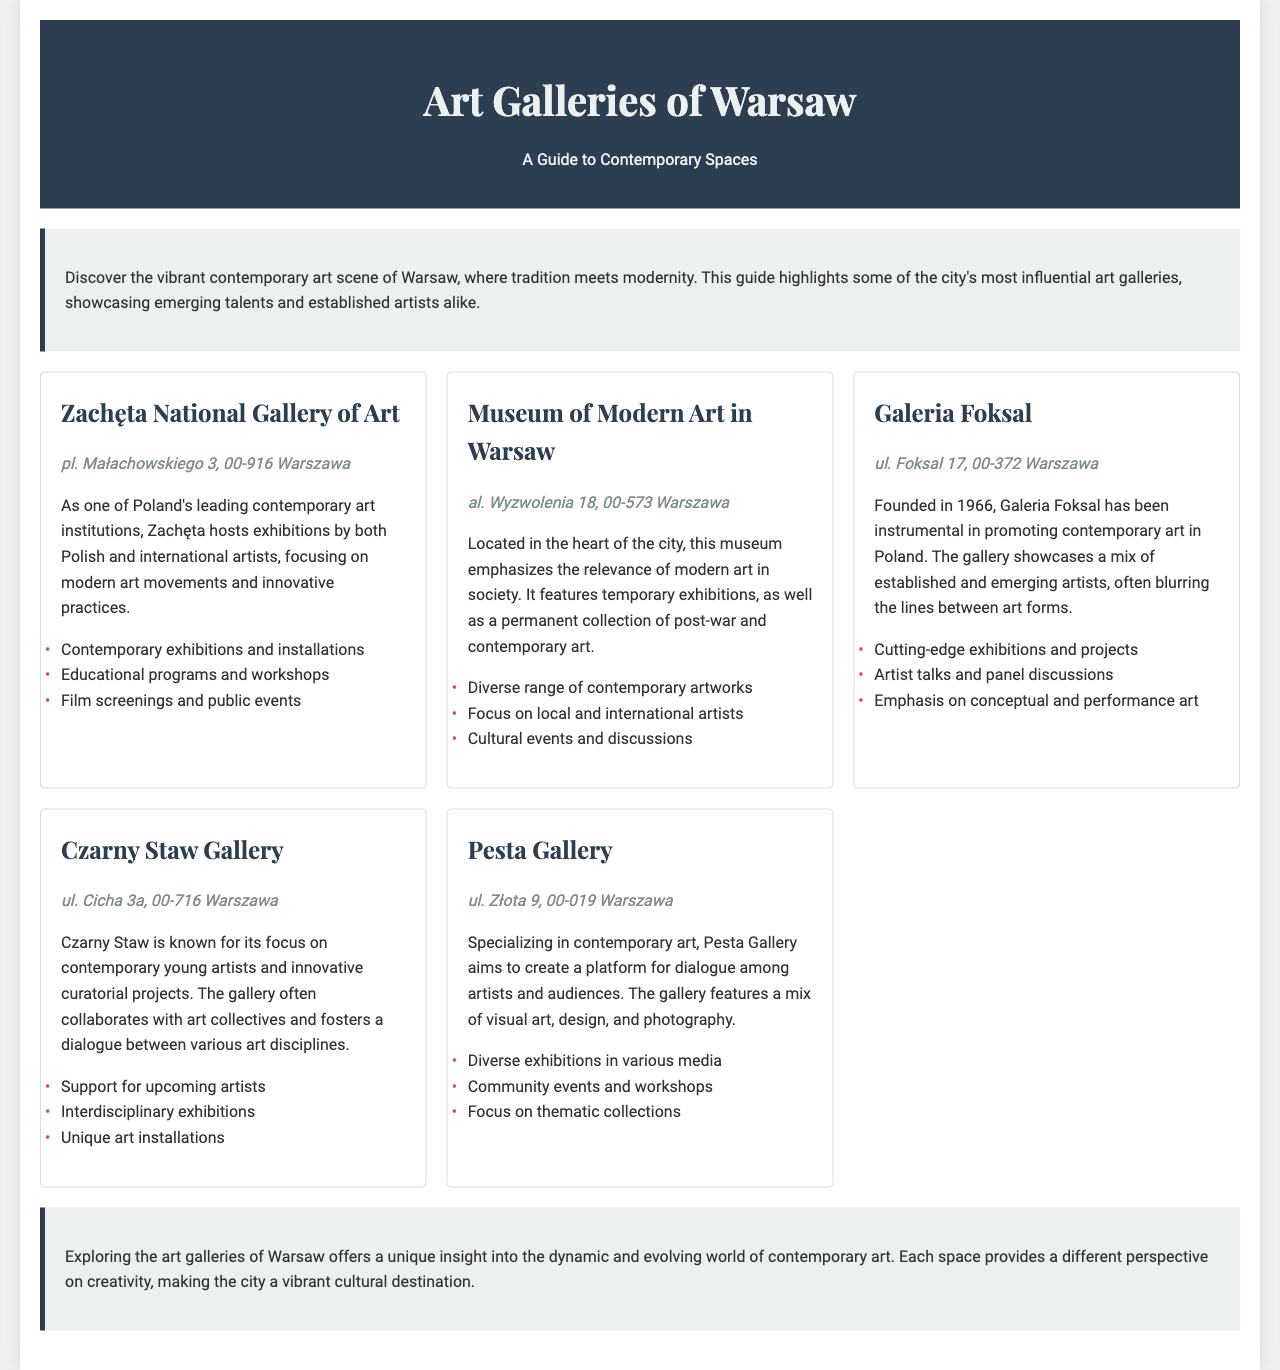What is the address of Zachęta National Gallery of Art? The address of Zachęta National Gallery of Art is provided in the document.
Answer: pl. Małachowskiego 3, 00-916 Warszawa How many galleries are listed in the document? The document features a total of five art galleries.
Answer: 5 Which gallery focuses on support for upcoming artists? This information is related to Czarny Staw Gallery, highlighting its emphasis on young and innovative artists.
Answer: Czarny Staw Gallery What type of events does Pesta Gallery offer? The document mentions that Pesta Gallery hosts community events and workshops, indicating its engagement with the public.
Answer: Community events and workshops Which gallery was founded in 1966? The document states that Galeria Foksal has been instrumental in promoting contemporary art since its founding year, 1966.
Answer: Galeria Foksal What is emphasized at the Museum of Modern Art in Warsaw? The Museum of Modern Art in Warsaw emphasizes the relevance of modern art in society, as indicated in the description.
Answer: Relevance of modern art What is a common theme among the galleries listed? The document discusses a focus on contemporary art, which is a shared theme among all the galleries mentioned.
Answer: Contemporary art What is noted about the exhibitions at Czarny Staw Gallery? The document describes Czarny Staw Gallery as hosting interdisciplinary exhibitions, which shows its innovative approach to curatorial projects.
Answer: Interdisciplinary exhibitions 